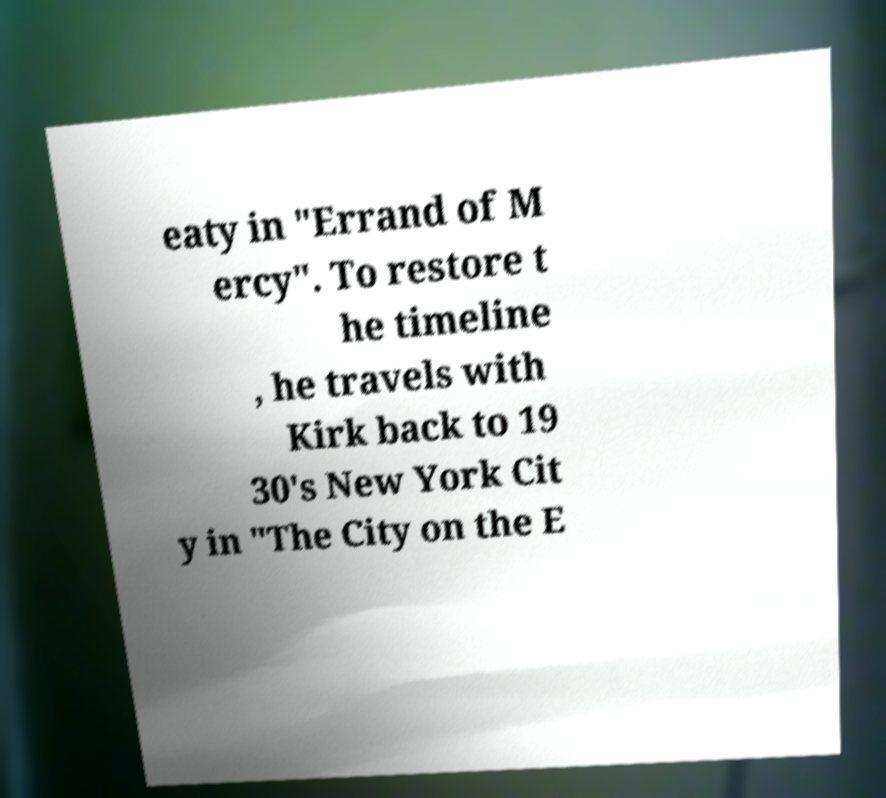Please read and relay the text visible in this image. What does it say? eaty in "Errand of M ercy". To restore t he timeline , he travels with Kirk back to 19 30's New York Cit y in "The City on the E 